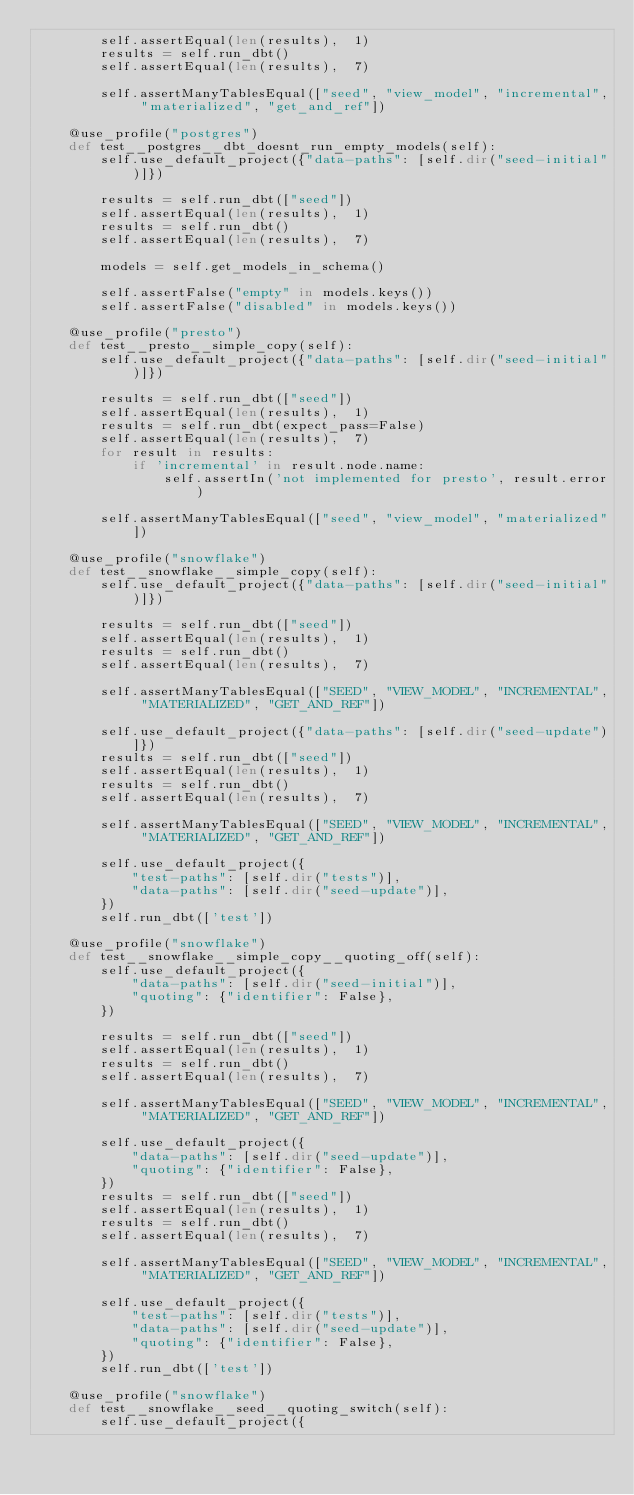<code> <loc_0><loc_0><loc_500><loc_500><_Python_>        self.assertEqual(len(results),  1)
        results = self.run_dbt()
        self.assertEqual(len(results),  7)

        self.assertManyTablesEqual(["seed", "view_model", "incremental", "materialized", "get_and_ref"])

    @use_profile("postgres")
    def test__postgres__dbt_doesnt_run_empty_models(self):
        self.use_default_project({"data-paths": [self.dir("seed-initial")]})

        results = self.run_dbt(["seed"])
        self.assertEqual(len(results),  1)
        results = self.run_dbt()
        self.assertEqual(len(results),  7)

        models = self.get_models_in_schema()

        self.assertFalse("empty" in models.keys())
        self.assertFalse("disabled" in models.keys())

    @use_profile("presto")
    def test__presto__simple_copy(self):
        self.use_default_project({"data-paths": [self.dir("seed-initial")]})

        results = self.run_dbt(["seed"])
        self.assertEqual(len(results),  1)
        results = self.run_dbt(expect_pass=False)
        self.assertEqual(len(results),  7)
        for result in results:
            if 'incremental' in result.node.name:
                self.assertIn('not implemented for presto', result.error)

        self.assertManyTablesEqual(["seed", "view_model", "materialized"])

    @use_profile("snowflake")
    def test__snowflake__simple_copy(self):
        self.use_default_project({"data-paths": [self.dir("seed-initial")]})

        results = self.run_dbt(["seed"])
        self.assertEqual(len(results),  1)
        results = self.run_dbt()
        self.assertEqual(len(results),  7)

        self.assertManyTablesEqual(["SEED", "VIEW_MODEL", "INCREMENTAL", "MATERIALIZED", "GET_AND_REF"])

        self.use_default_project({"data-paths": [self.dir("seed-update")]})
        results = self.run_dbt(["seed"])
        self.assertEqual(len(results),  1)
        results = self.run_dbt()
        self.assertEqual(len(results),  7)

        self.assertManyTablesEqual(["SEED", "VIEW_MODEL", "INCREMENTAL", "MATERIALIZED", "GET_AND_REF"])

        self.use_default_project({
            "test-paths": [self.dir("tests")],
            "data-paths": [self.dir("seed-update")],
        })
        self.run_dbt(['test'])

    @use_profile("snowflake")
    def test__snowflake__simple_copy__quoting_off(self):
        self.use_default_project({
            "data-paths": [self.dir("seed-initial")],
            "quoting": {"identifier": False},
        })

        results = self.run_dbt(["seed"])
        self.assertEqual(len(results),  1)
        results = self.run_dbt()
        self.assertEqual(len(results),  7)

        self.assertManyTablesEqual(["SEED", "VIEW_MODEL", "INCREMENTAL", "MATERIALIZED", "GET_AND_REF"])

        self.use_default_project({
            "data-paths": [self.dir("seed-update")],
            "quoting": {"identifier": False},
        })
        results = self.run_dbt(["seed"])
        self.assertEqual(len(results),  1)
        results = self.run_dbt()
        self.assertEqual(len(results),  7)

        self.assertManyTablesEqual(["SEED", "VIEW_MODEL", "INCREMENTAL", "MATERIALIZED", "GET_AND_REF"])

        self.use_default_project({
            "test-paths": [self.dir("tests")],
            "data-paths": [self.dir("seed-update")],
            "quoting": {"identifier": False},
        })
        self.run_dbt(['test'])

    @use_profile("snowflake")
    def test__snowflake__seed__quoting_switch(self):
        self.use_default_project({</code> 